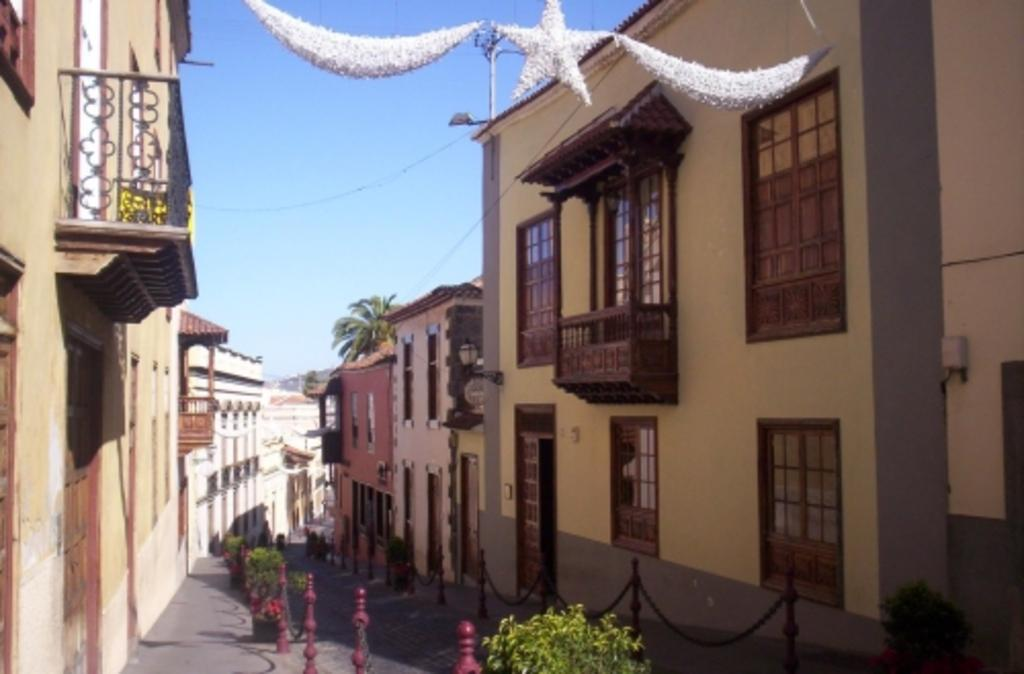What type of structures can be seen in the image? There are many buildings in the image. What is located at the bottom of the image? There is a railing with chains at the bottom of the image. What is visible at the top of the image? The sky is visible at the top of the image. What type of pathway is present in the image? There is a road at the bottom of the image. How many cats can be seen playing with lumber in the image? There are no cats or lumber present in the image. 